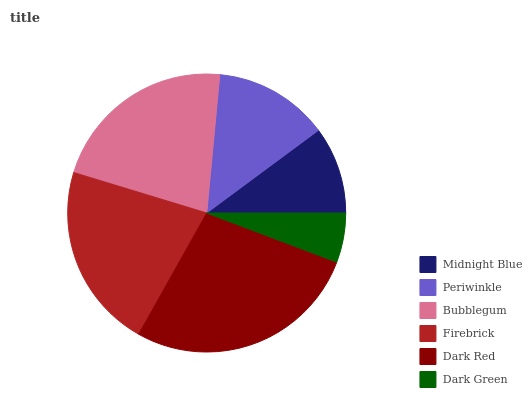Is Dark Green the minimum?
Answer yes or no. Yes. Is Dark Red the maximum?
Answer yes or no. Yes. Is Periwinkle the minimum?
Answer yes or no. No. Is Periwinkle the maximum?
Answer yes or no. No. Is Periwinkle greater than Midnight Blue?
Answer yes or no. Yes. Is Midnight Blue less than Periwinkle?
Answer yes or no. Yes. Is Midnight Blue greater than Periwinkle?
Answer yes or no. No. Is Periwinkle less than Midnight Blue?
Answer yes or no. No. Is Firebrick the high median?
Answer yes or no. Yes. Is Periwinkle the low median?
Answer yes or no. Yes. Is Midnight Blue the high median?
Answer yes or no. No. Is Bubblegum the low median?
Answer yes or no. No. 